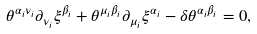<formula> <loc_0><loc_0><loc_500><loc_500>\theta ^ { \alpha _ { i } \nu _ { i } } \partial _ { \nu _ { i } } \xi ^ { \beta _ { i } } + \theta ^ { \mu _ { i } \beta _ { i } } \partial _ { \mu _ { i } } \xi ^ { \alpha _ { i } } - \delta \theta ^ { \alpha _ { i } \beta _ { i } } = 0 ,</formula> 